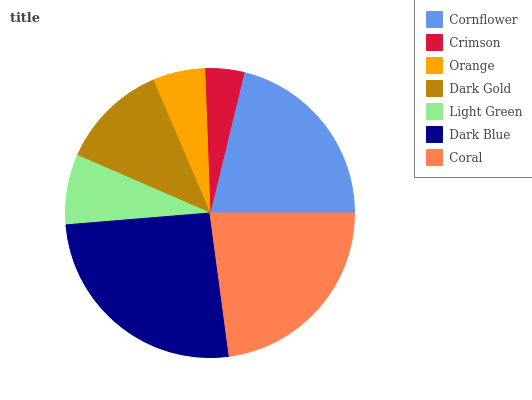Is Crimson the minimum?
Answer yes or no. Yes. Is Dark Blue the maximum?
Answer yes or no. Yes. Is Orange the minimum?
Answer yes or no. No. Is Orange the maximum?
Answer yes or no. No. Is Orange greater than Crimson?
Answer yes or no. Yes. Is Crimson less than Orange?
Answer yes or no. Yes. Is Crimson greater than Orange?
Answer yes or no. No. Is Orange less than Crimson?
Answer yes or no. No. Is Dark Gold the high median?
Answer yes or no. Yes. Is Dark Gold the low median?
Answer yes or no. Yes. Is Crimson the high median?
Answer yes or no. No. Is Orange the low median?
Answer yes or no. No. 